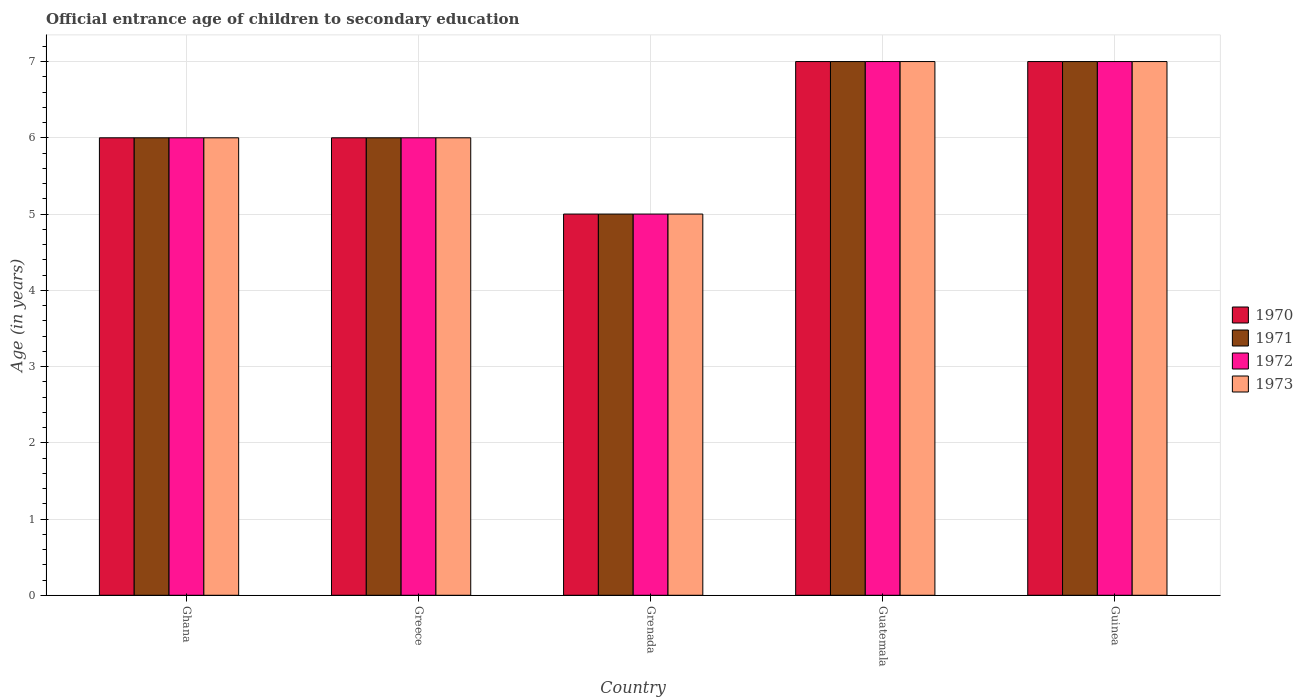Are the number of bars per tick equal to the number of legend labels?
Keep it short and to the point. Yes. How many bars are there on the 5th tick from the left?
Your answer should be very brief. 4. How many bars are there on the 2nd tick from the right?
Your response must be concise. 4. What is the label of the 4th group of bars from the left?
Ensure brevity in your answer.  Guatemala. Across all countries, what is the minimum secondary school starting age of children in 1970?
Provide a succinct answer. 5. In which country was the secondary school starting age of children in 1973 maximum?
Give a very brief answer. Guatemala. In which country was the secondary school starting age of children in 1970 minimum?
Your answer should be compact. Grenada. What is the average secondary school starting age of children in 1971 per country?
Ensure brevity in your answer.  6.2. What is the difference between the secondary school starting age of children of/in 1972 and secondary school starting age of children of/in 1970 in Ghana?
Make the answer very short. 0. In how many countries, is the secondary school starting age of children in 1970 greater than 5.6 years?
Offer a terse response. 4. Is the secondary school starting age of children in 1973 in Greece less than that in Guinea?
Give a very brief answer. Yes. What is the difference between the highest and the second highest secondary school starting age of children in 1971?
Keep it short and to the point. -1. In how many countries, is the secondary school starting age of children in 1971 greater than the average secondary school starting age of children in 1971 taken over all countries?
Offer a very short reply. 2. Is the sum of the secondary school starting age of children in 1972 in Ghana and Guinea greater than the maximum secondary school starting age of children in 1970 across all countries?
Make the answer very short. Yes. Is it the case that in every country, the sum of the secondary school starting age of children in 1972 and secondary school starting age of children in 1971 is greater than the sum of secondary school starting age of children in 1973 and secondary school starting age of children in 1970?
Your answer should be very brief. No. What does the 2nd bar from the right in Greece represents?
Provide a short and direct response. 1972. Is it the case that in every country, the sum of the secondary school starting age of children in 1972 and secondary school starting age of children in 1970 is greater than the secondary school starting age of children in 1973?
Ensure brevity in your answer.  Yes. How many bars are there?
Your response must be concise. 20. Are all the bars in the graph horizontal?
Make the answer very short. No. Are the values on the major ticks of Y-axis written in scientific E-notation?
Your answer should be compact. No. Does the graph contain grids?
Offer a terse response. Yes. How many legend labels are there?
Ensure brevity in your answer.  4. What is the title of the graph?
Ensure brevity in your answer.  Official entrance age of children to secondary education. What is the label or title of the X-axis?
Make the answer very short. Country. What is the label or title of the Y-axis?
Provide a succinct answer. Age (in years). What is the Age (in years) of 1970 in Ghana?
Provide a succinct answer. 6. What is the Age (in years) of 1971 in Ghana?
Keep it short and to the point. 6. What is the Age (in years) in 1972 in Ghana?
Offer a very short reply. 6. What is the Age (in years) in 1973 in Ghana?
Ensure brevity in your answer.  6. What is the Age (in years) in 1970 in Greece?
Offer a very short reply. 6. What is the Age (in years) in 1972 in Grenada?
Your response must be concise. 5. What is the Age (in years) in 1971 in Guatemala?
Offer a very short reply. 7. What is the Age (in years) in 1972 in Guatemala?
Provide a succinct answer. 7. What is the Age (in years) of 1972 in Guinea?
Provide a short and direct response. 7. Across all countries, what is the maximum Age (in years) of 1970?
Ensure brevity in your answer.  7. Across all countries, what is the maximum Age (in years) of 1971?
Give a very brief answer. 7. Across all countries, what is the minimum Age (in years) of 1971?
Provide a short and direct response. 5. Across all countries, what is the minimum Age (in years) of 1972?
Provide a short and direct response. 5. What is the total Age (in years) in 1971 in the graph?
Your answer should be compact. 31. What is the total Age (in years) in 1972 in the graph?
Make the answer very short. 31. What is the total Age (in years) of 1973 in the graph?
Provide a short and direct response. 31. What is the difference between the Age (in years) of 1973 in Ghana and that in Greece?
Offer a terse response. 0. What is the difference between the Age (in years) in 1970 in Ghana and that in Grenada?
Your answer should be compact. 1. What is the difference between the Age (in years) in 1970 in Ghana and that in Guatemala?
Provide a short and direct response. -1. What is the difference between the Age (in years) of 1973 in Ghana and that in Guatemala?
Give a very brief answer. -1. What is the difference between the Age (in years) of 1970 in Ghana and that in Guinea?
Give a very brief answer. -1. What is the difference between the Age (in years) in 1971 in Ghana and that in Guinea?
Offer a terse response. -1. What is the difference between the Age (in years) in 1970 in Greece and that in Grenada?
Offer a terse response. 1. What is the difference between the Age (in years) in 1973 in Greece and that in Grenada?
Your answer should be compact. 1. What is the difference between the Age (in years) of 1971 in Greece and that in Guatemala?
Offer a terse response. -1. What is the difference between the Age (in years) of 1972 in Greece and that in Guatemala?
Your answer should be compact. -1. What is the difference between the Age (in years) of 1973 in Greece and that in Guatemala?
Ensure brevity in your answer.  -1. What is the difference between the Age (in years) in 1970 in Greece and that in Guinea?
Keep it short and to the point. -1. What is the difference between the Age (in years) in 1971 in Greece and that in Guinea?
Provide a succinct answer. -1. What is the difference between the Age (in years) in 1972 in Grenada and that in Guatemala?
Your answer should be very brief. -2. What is the difference between the Age (in years) of 1970 in Grenada and that in Guinea?
Offer a terse response. -2. What is the difference between the Age (in years) in 1971 in Grenada and that in Guinea?
Keep it short and to the point. -2. What is the difference between the Age (in years) in 1973 in Grenada and that in Guinea?
Provide a succinct answer. -2. What is the difference between the Age (in years) of 1970 in Guatemala and that in Guinea?
Provide a succinct answer. 0. What is the difference between the Age (in years) in 1973 in Guatemala and that in Guinea?
Your answer should be compact. 0. What is the difference between the Age (in years) in 1970 in Ghana and the Age (in years) in 1971 in Greece?
Your answer should be very brief. 0. What is the difference between the Age (in years) of 1970 in Ghana and the Age (in years) of 1973 in Greece?
Provide a short and direct response. 0. What is the difference between the Age (in years) in 1971 in Ghana and the Age (in years) in 1973 in Greece?
Your answer should be very brief. 0. What is the difference between the Age (in years) of 1970 in Ghana and the Age (in years) of 1971 in Grenada?
Your answer should be compact. 1. What is the difference between the Age (in years) of 1970 in Ghana and the Age (in years) of 1973 in Grenada?
Give a very brief answer. 1. What is the difference between the Age (in years) of 1971 in Ghana and the Age (in years) of 1972 in Grenada?
Keep it short and to the point. 1. What is the difference between the Age (in years) of 1971 in Ghana and the Age (in years) of 1973 in Grenada?
Offer a terse response. 1. What is the difference between the Age (in years) of 1970 in Ghana and the Age (in years) of 1971 in Guatemala?
Give a very brief answer. -1. What is the difference between the Age (in years) of 1971 in Ghana and the Age (in years) of 1973 in Guatemala?
Offer a terse response. -1. What is the difference between the Age (in years) of 1971 in Ghana and the Age (in years) of 1972 in Guinea?
Provide a succinct answer. -1. What is the difference between the Age (in years) in 1970 in Greece and the Age (in years) in 1972 in Grenada?
Your answer should be compact. 1. What is the difference between the Age (in years) in 1971 in Greece and the Age (in years) in 1972 in Grenada?
Your answer should be very brief. 1. What is the difference between the Age (in years) of 1972 in Greece and the Age (in years) of 1973 in Grenada?
Make the answer very short. 1. What is the difference between the Age (in years) in 1970 in Greece and the Age (in years) in 1972 in Guatemala?
Provide a succinct answer. -1. What is the difference between the Age (in years) in 1970 in Greece and the Age (in years) in 1973 in Guatemala?
Keep it short and to the point. -1. What is the difference between the Age (in years) in 1972 in Greece and the Age (in years) in 1973 in Guatemala?
Give a very brief answer. -1. What is the difference between the Age (in years) in 1970 in Greece and the Age (in years) in 1971 in Guinea?
Ensure brevity in your answer.  -1. What is the difference between the Age (in years) in 1971 in Greece and the Age (in years) in 1973 in Guinea?
Give a very brief answer. -1. What is the difference between the Age (in years) of 1972 in Greece and the Age (in years) of 1973 in Guinea?
Keep it short and to the point. -1. What is the difference between the Age (in years) of 1970 in Grenada and the Age (in years) of 1971 in Guatemala?
Your response must be concise. -2. What is the difference between the Age (in years) in 1970 in Grenada and the Age (in years) in 1972 in Guatemala?
Your answer should be compact. -2. What is the difference between the Age (in years) of 1971 in Grenada and the Age (in years) of 1972 in Guatemala?
Keep it short and to the point. -2. What is the difference between the Age (in years) in 1971 in Grenada and the Age (in years) in 1973 in Guatemala?
Offer a terse response. -2. What is the difference between the Age (in years) of 1970 in Grenada and the Age (in years) of 1972 in Guinea?
Provide a succinct answer. -2. What is the difference between the Age (in years) of 1970 in Grenada and the Age (in years) of 1973 in Guinea?
Keep it short and to the point. -2. What is the difference between the Age (in years) of 1970 in Guatemala and the Age (in years) of 1972 in Guinea?
Ensure brevity in your answer.  0. What is the difference between the Age (in years) in 1970 in Guatemala and the Age (in years) in 1973 in Guinea?
Provide a short and direct response. 0. What is the difference between the Age (in years) in 1971 in Guatemala and the Age (in years) in 1973 in Guinea?
Provide a succinct answer. 0. What is the average Age (in years) in 1971 per country?
Give a very brief answer. 6.2. What is the average Age (in years) of 1972 per country?
Your response must be concise. 6.2. What is the difference between the Age (in years) in 1971 and Age (in years) in 1972 in Ghana?
Your response must be concise. 0. What is the difference between the Age (in years) in 1972 and Age (in years) in 1973 in Ghana?
Your response must be concise. 0. What is the difference between the Age (in years) in 1970 and Age (in years) in 1972 in Greece?
Ensure brevity in your answer.  0. What is the difference between the Age (in years) of 1970 and Age (in years) of 1973 in Greece?
Offer a very short reply. 0. What is the difference between the Age (in years) in 1971 and Age (in years) in 1973 in Greece?
Your answer should be compact. 0. What is the difference between the Age (in years) of 1970 and Age (in years) of 1972 in Grenada?
Keep it short and to the point. 0. What is the difference between the Age (in years) of 1972 and Age (in years) of 1973 in Grenada?
Make the answer very short. 0. What is the difference between the Age (in years) of 1970 and Age (in years) of 1971 in Guatemala?
Provide a succinct answer. 0. What is the difference between the Age (in years) of 1970 and Age (in years) of 1972 in Guatemala?
Ensure brevity in your answer.  0. What is the difference between the Age (in years) in 1970 and Age (in years) in 1973 in Guatemala?
Your response must be concise. 0. What is the difference between the Age (in years) in 1971 and Age (in years) in 1972 in Guatemala?
Offer a terse response. 0. What is the difference between the Age (in years) in 1972 and Age (in years) in 1973 in Guatemala?
Provide a short and direct response. 0. What is the difference between the Age (in years) of 1970 and Age (in years) of 1971 in Guinea?
Your answer should be very brief. 0. What is the difference between the Age (in years) in 1970 and Age (in years) in 1972 in Guinea?
Ensure brevity in your answer.  0. What is the difference between the Age (in years) in 1971 and Age (in years) in 1972 in Guinea?
Keep it short and to the point. 0. What is the ratio of the Age (in years) in 1971 in Ghana to that in Greece?
Keep it short and to the point. 1. What is the ratio of the Age (in years) of 1972 in Ghana to that in Greece?
Offer a very short reply. 1. What is the ratio of the Age (in years) of 1973 in Ghana to that in Greece?
Keep it short and to the point. 1. What is the ratio of the Age (in years) in 1971 in Ghana to that in Grenada?
Provide a succinct answer. 1.2. What is the ratio of the Age (in years) in 1972 in Ghana to that in Grenada?
Keep it short and to the point. 1.2. What is the ratio of the Age (in years) in 1970 in Ghana to that in Guatemala?
Provide a succinct answer. 0.86. What is the ratio of the Age (in years) in 1971 in Ghana to that in Guatemala?
Offer a very short reply. 0.86. What is the ratio of the Age (in years) of 1972 in Ghana to that in Guatemala?
Make the answer very short. 0.86. What is the ratio of the Age (in years) of 1972 in Ghana to that in Guinea?
Make the answer very short. 0.86. What is the ratio of the Age (in years) of 1970 in Greece to that in Guatemala?
Your answer should be very brief. 0.86. What is the ratio of the Age (in years) of 1972 in Greece to that in Guatemala?
Offer a terse response. 0.86. What is the ratio of the Age (in years) in 1972 in Greece to that in Guinea?
Provide a short and direct response. 0.86. What is the ratio of the Age (in years) of 1970 in Grenada to that in Guatemala?
Provide a succinct answer. 0.71. What is the ratio of the Age (in years) of 1971 in Grenada to that in Guatemala?
Make the answer very short. 0.71. What is the ratio of the Age (in years) of 1972 in Grenada to that in Guinea?
Your answer should be compact. 0.71. What is the ratio of the Age (in years) of 1973 in Grenada to that in Guinea?
Provide a succinct answer. 0.71. What is the difference between the highest and the second highest Age (in years) in 1973?
Provide a short and direct response. 0. What is the difference between the highest and the lowest Age (in years) in 1972?
Provide a succinct answer. 2. What is the difference between the highest and the lowest Age (in years) of 1973?
Offer a terse response. 2. 